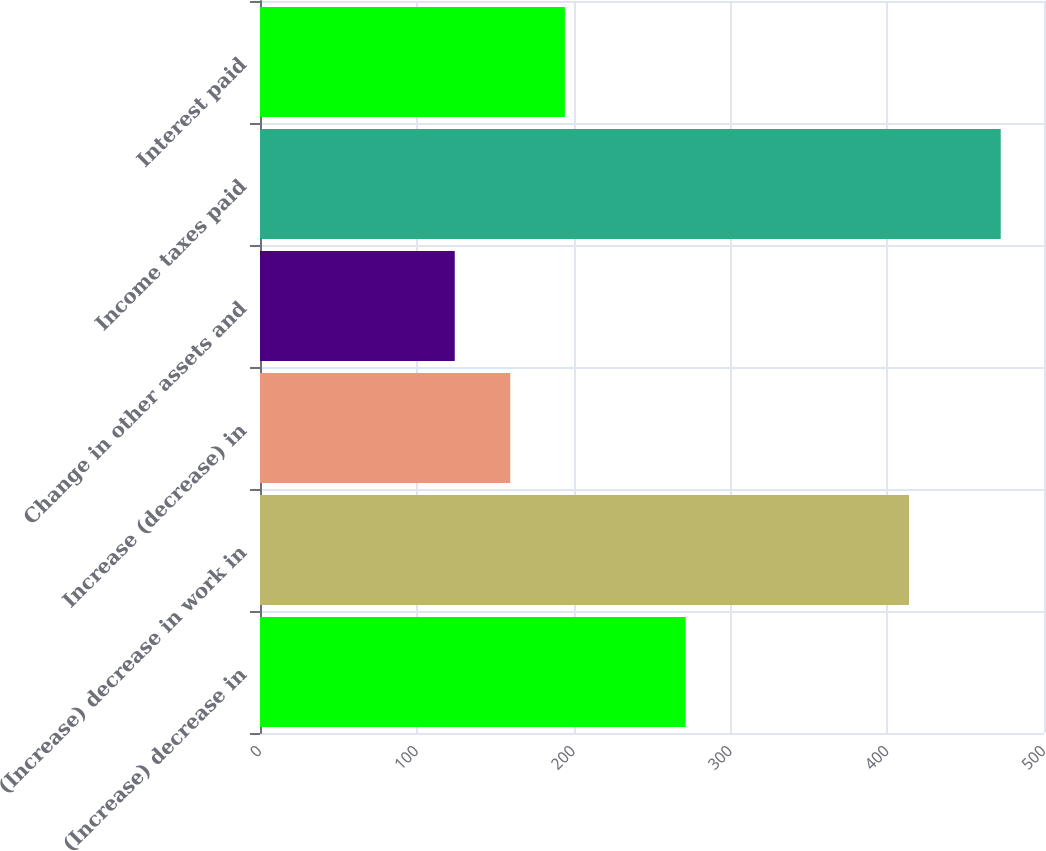Convert chart. <chart><loc_0><loc_0><loc_500><loc_500><bar_chart><fcel>(Increase) decrease in<fcel>(Increase) decrease in work in<fcel>Increase (decrease) in<fcel>Change in other assets and<fcel>Income taxes paid<fcel>Interest paid<nl><fcel>271.42<fcel>413.9<fcel>159.6<fcel>124.2<fcel>472.4<fcel>194.42<nl></chart> 